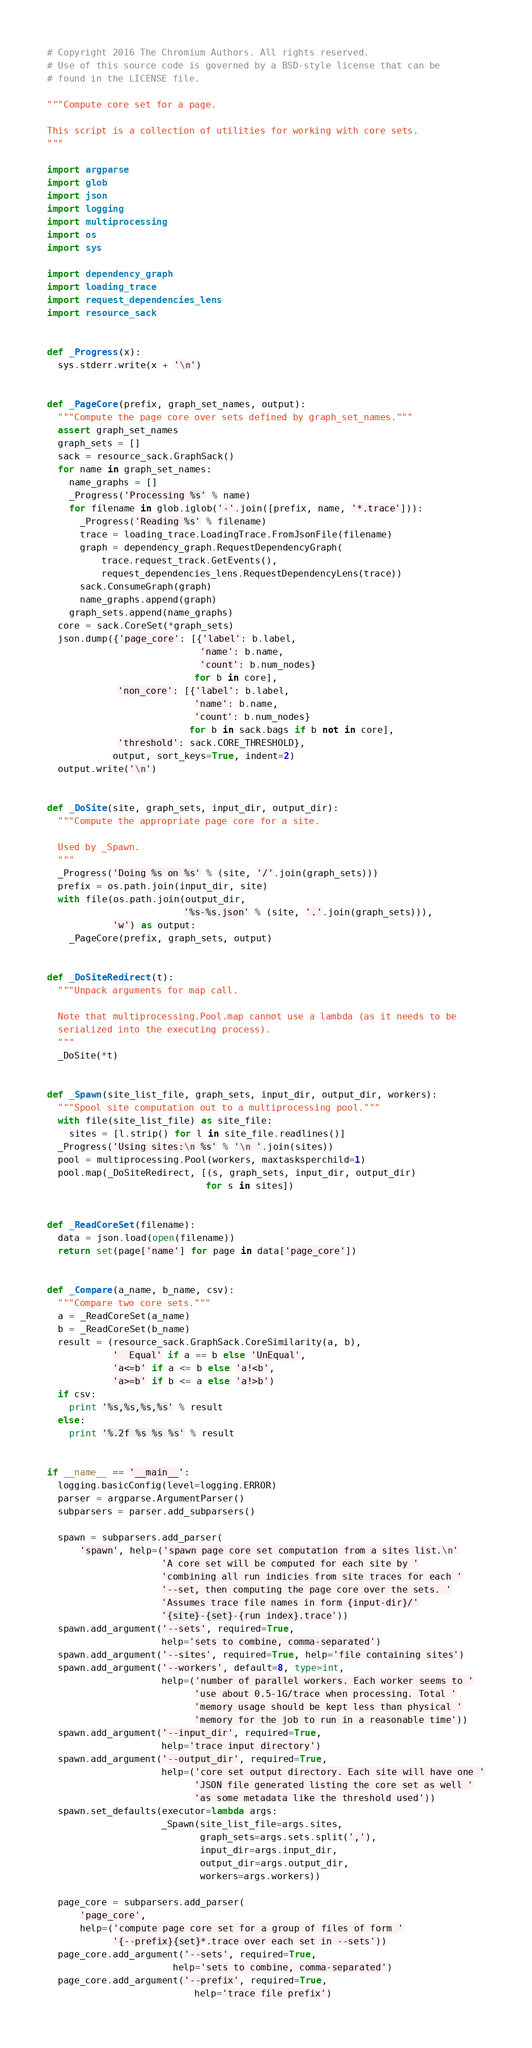Convert code to text. <code><loc_0><loc_0><loc_500><loc_500><_Python_># Copyright 2016 The Chromium Authors. All rights reserved.
# Use of this source code is governed by a BSD-style license that can be
# found in the LICENSE file.

"""Compute core set for a page.

This script is a collection of utilities for working with core sets.
"""

import argparse
import glob
import json
import logging
import multiprocessing
import os
import sys

import dependency_graph
import loading_trace
import request_dependencies_lens
import resource_sack


def _Progress(x):
  sys.stderr.write(x + '\n')


def _PageCore(prefix, graph_set_names, output):
  """Compute the page core over sets defined by graph_set_names."""
  assert graph_set_names
  graph_sets = []
  sack = resource_sack.GraphSack()
  for name in graph_set_names:
    name_graphs = []
    _Progress('Processing %s' % name)
    for filename in glob.iglob('-'.join([prefix, name, '*.trace'])):
      _Progress('Reading %s' % filename)
      trace = loading_trace.LoadingTrace.FromJsonFile(filename)
      graph = dependency_graph.RequestDependencyGraph(
          trace.request_track.GetEvents(),
          request_dependencies_lens.RequestDependencyLens(trace))
      sack.ConsumeGraph(graph)
      name_graphs.append(graph)
    graph_sets.append(name_graphs)
  core = sack.CoreSet(*graph_sets)
  json.dump({'page_core': [{'label': b.label,
                            'name': b.name,
                            'count': b.num_nodes}
                           for b in core],
             'non_core': [{'label': b.label,
                           'name': b.name,
                           'count': b.num_nodes}
                          for b in sack.bags if b not in core],
             'threshold': sack.CORE_THRESHOLD},
            output, sort_keys=True, indent=2)
  output.write('\n')


def _DoSite(site, graph_sets, input_dir, output_dir):
  """Compute the appropriate page core for a site.

  Used by _Spawn.
  """
  _Progress('Doing %s on %s' % (site, '/'.join(graph_sets)))
  prefix = os.path.join(input_dir, site)
  with file(os.path.join(output_dir,
                         '%s-%s.json' % (site, '.'.join(graph_sets))),
            'w') as output:
    _PageCore(prefix, graph_sets, output)


def _DoSiteRedirect(t):
  """Unpack arguments for map call.

  Note that multiprocessing.Pool.map cannot use a lambda (as it needs to be
  serialized into the executing process).
  """
  _DoSite(*t)


def _Spawn(site_list_file, graph_sets, input_dir, output_dir, workers):
  """Spool site computation out to a multiprocessing pool."""
  with file(site_list_file) as site_file:
    sites = [l.strip() for l in site_file.readlines()]
  _Progress('Using sites:\n %s' % '\n '.join(sites))
  pool = multiprocessing.Pool(workers, maxtasksperchild=1)
  pool.map(_DoSiteRedirect, [(s, graph_sets, input_dir, output_dir)
                             for s in sites])


def _ReadCoreSet(filename):
  data = json.load(open(filename))
  return set(page['name'] for page in data['page_core'])


def _Compare(a_name, b_name, csv):
  """Compare two core sets."""
  a = _ReadCoreSet(a_name)
  b = _ReadCoreSet(b_name)
  result = (resource_sack.GraphSack.CoreSimilarity(a, b),
            '  Equal' if a == b else 'UnEqual',
            'a<=b' if a <= b else 'a!<b',
            'a>=b' if b <= a else 'a!>b')
  if csv:
    print '%s,%s,%s,%s' % result
  else:
    print '%.2f %s %s %s' % result


if __name__ == '__main__':
  logging.basicConfig(level=logging.ERROR)
  parser = argparse.ArgumentParser()
  subparsers = parser.add_subparsers()

  spawn = subparsers.add_parser(
      'spawn', help=('spawn page core set computation from a sites list.\n'
                     'A core set will be computed for each site by '
                     'combining all run indicies from site traces for each '
                     '--set, then computing the page core over the sets. '
                     'Assumes trace file names in form {input-dir}/'
                     '{site}-{set}-{run index}.trace'))
  spawn.add_argument('--sets', required=True,
                     help='sets to combine, comma-separated')
  spawn.add_argument('--sites', required=True, help='file containing sites')
  spawn.add_argument('--workers', default=8, type=int,
                     help=('number of parallel workers. Each worker seems to '
                           'use about 0.5-1G/trace when processing. Total '
                           'memory usage should be kept less than physical '
                           'memory for the job to run in a reasonable time'))
  spawn.add_argument('--input_dir', required=True,
                     help='trace input directory')
  spawn.add_argument('--output_dir', required=True,
                     help=('core set output directory. Each site will have one '
                           'JSON file generated listing the core set as well '
                           'as some metadata like the threshold used'))
  spawn.set_defaults(executor=lambda args:
                     _Spawn(site_list_file=args.sites,
                            graph_sets=args.sets.split(','),
                            input_dir=args.input_dir,
                            output_dir=args.output_dir,
                            workers=args.workers))

  page_core = subparsers.add_parser(
      'page_core',
      help=('compute page core set for a group of files of form '
            '{--prefix}{set}*.trace over each set in --sets'))
  page_core.add_argument('--sets', required=True,
                       help='sets to combine, comma-separated')
  page_core.add_argument('--prefix', required=True,
                           help='trace file prefix')</code> 